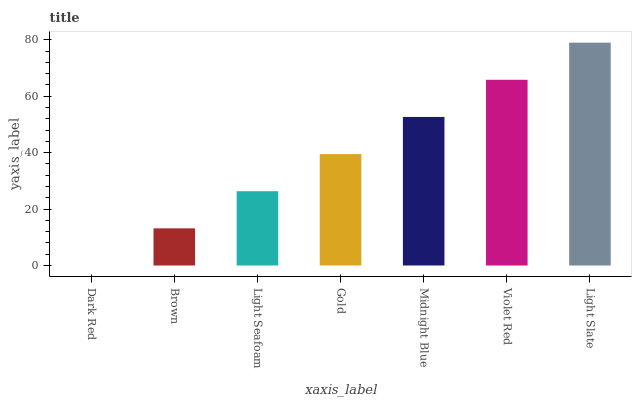Is Dark Red the minimum?
Answer yes or no. Yes. Is Light Slate the maximum?
Answer yes or no. Yes. Is Brown the minimum?
Answer yes or no. No. Is Brown the maximum?
Answer yes or no. No. Is Brown greater than Dark Red?
Answer yes or no. Yes. Is Dark Red less than Brown?
Answer yes or no. Yes. Is Dark Red greater than Brown?
Answer yes or no. No. Is Brown less than Dark Red?
Answer yes or no. No. Is Gold the high median?
Answer yes or no. Yes. Is Gold the low median?
Answer yes or no. Yes. Is Violet Red the high median?
Answer yes or no. No. Is Light Slate the low median?
Answer yes or no. No. 